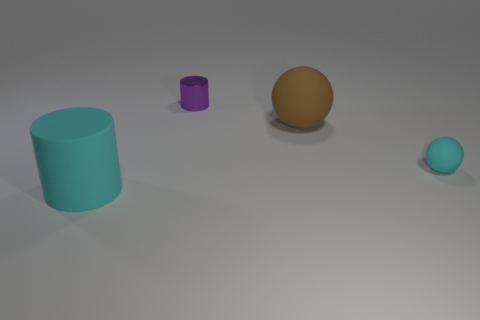Add 4 big green metal cubes. How many objects exist? 8 Subtract all purple things. Subtract all cyan cylinders. How many objects are left? 2 Add 1 cyan rubber things. How many cyan rubber things are left? 3 Add 4 yellow matte balls. How many yellow matte balls exist? 4 Subtract 0 yellow balls. How many objects are left? 4 